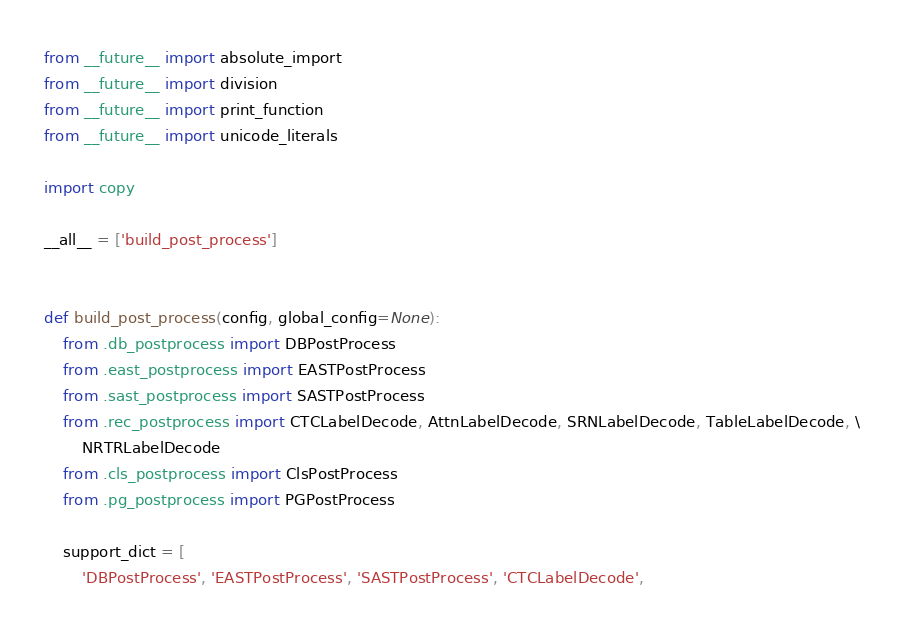Convert code to text. <code><loc_0><loc_0><loc_500><loc_500><_Python_>
from __future__ import absolute_import
from __future__ import division
from __future__ import print_function
from __future__ import unicode_literals

import copy

__all__ = ['build_post_process']


def build_post_process(config, global_config=None):
    from .db_postprocess import DBPostProcess
    from .east_postprocess import EASTPostProcess
    from .sast_postprocess import SASTPostProcess
    from .rec_postprocess import CTCLabelDecode, AttnLabelDecode, SRNLabelDecode, TableLabelDecode, \
        NRTRLabelDecode
    from .cls_postprocess import ClsPostProcess
    from .pg_postprocess import PGPostProcess

    support_dict = [
        'DBPostProcess', 'EASTPostProcess', 'SASTPostProcess', 'CTCLabelDecode',</code> 